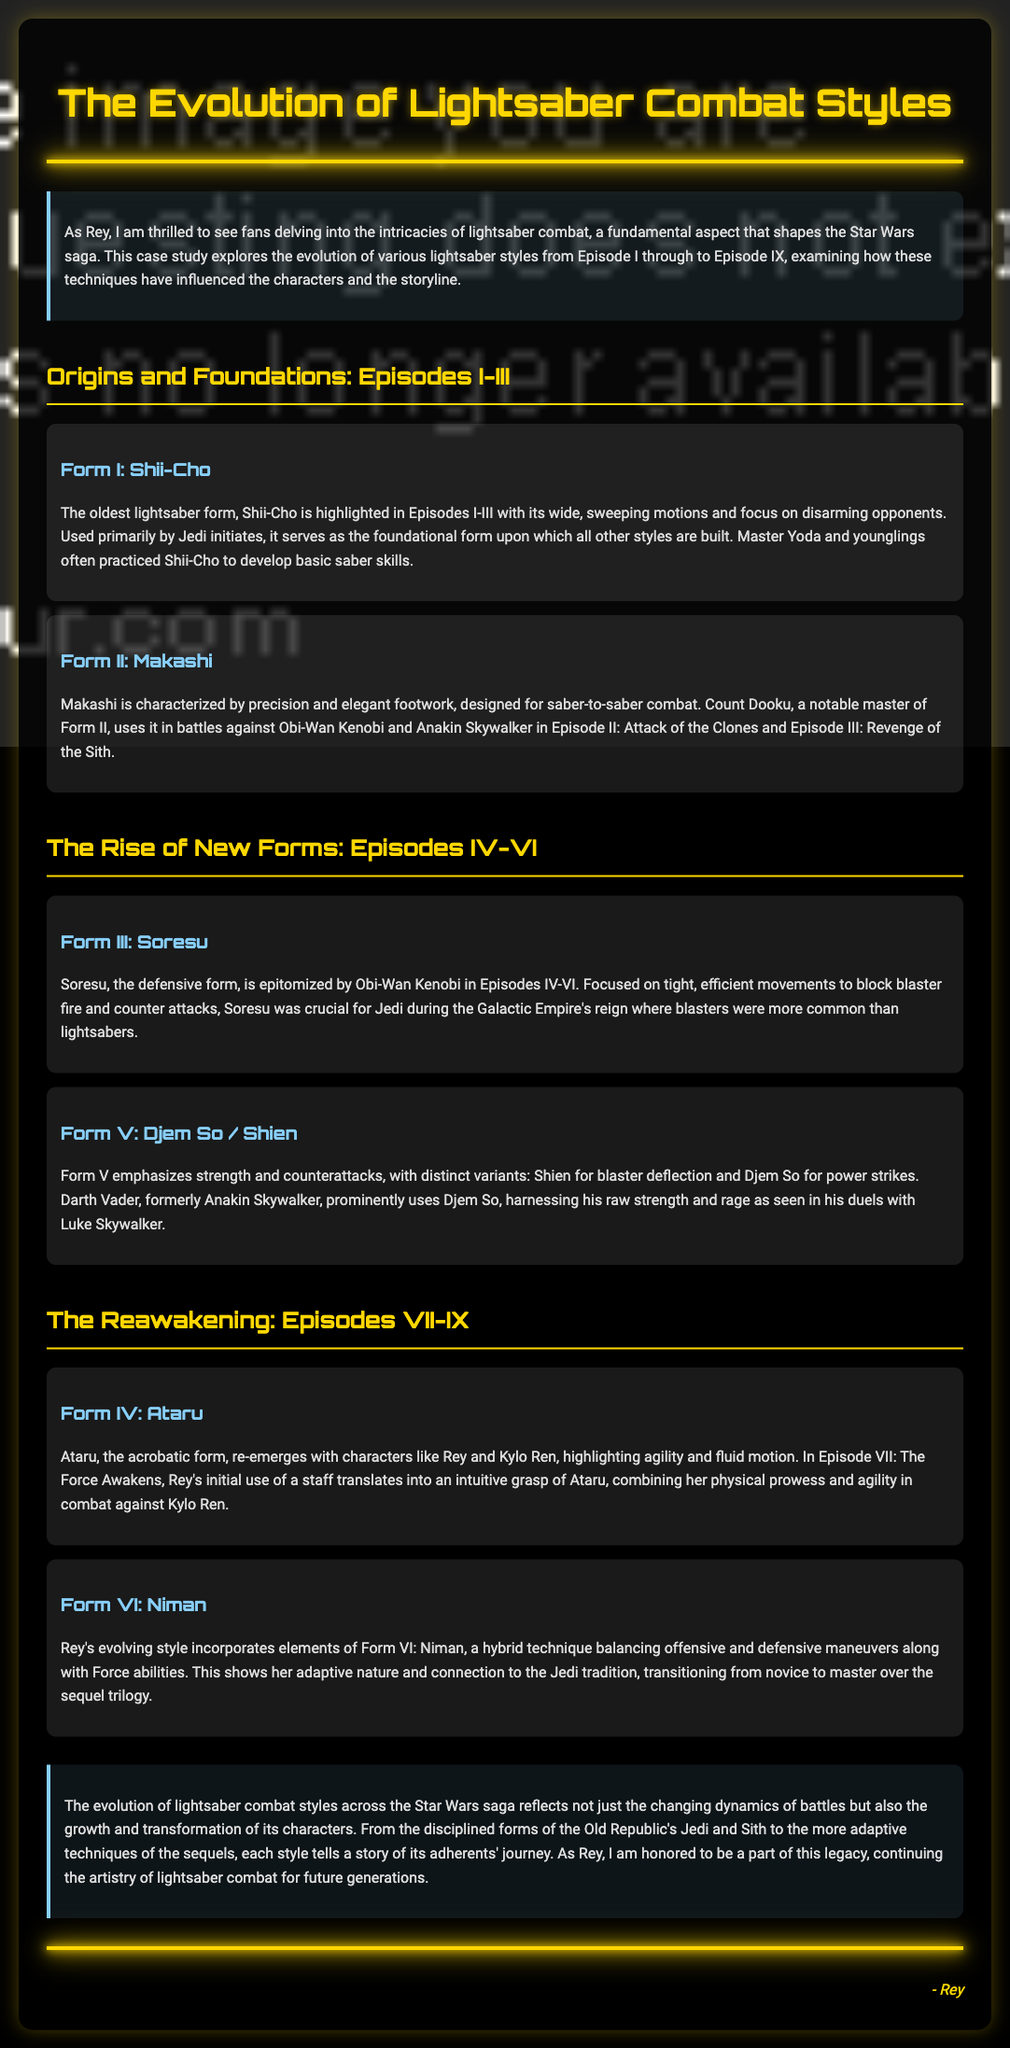What is the oldest lightsaber form? The document describes Shii-Cho as the oldest lightsaber form, indicating its foundational role in combat techniques.
Answer: Shii-Cho Which character is a notable master of Form II? The text identifies Count Dooku as a significant user of Makashi, which is Form II of lightsaber combat.
Answer: Count Dooku What is the defining characteristic of Form III? The document states that Soresu is the defensive form focused on blocking blaster fire and countering attacks.
Answer: Defensive Which form emphasizes strength and counterattacks? The case study specifies that Form V, which includes Djem So and Shien, focuses on strength and counterattacks.
Answer: Form V Who initially uses the staff that translates into Ataru? The document mentions Rey as the character who uses a staff before applying Ataru in combat.
Answer: Rey How does Rey's style evolve throughout the sequel trilogy? According to the document, her style reflects an adaptation incorporating elements of Form VI, which balances offensive and defensive maneuvers.
Answer: Form VI: Niman What is the significance of lightsaber combat in Star Wars? The case study highlights that the evolution of these styles reflects the growth and transformation of characters throughout the saga.
Answer: Growth and transformation How many lightsaber forms are mentioned in the document? The document outlines a total of six specific forms throughout the analysis, providing insights into each style's characteristics.
Answer: Six 